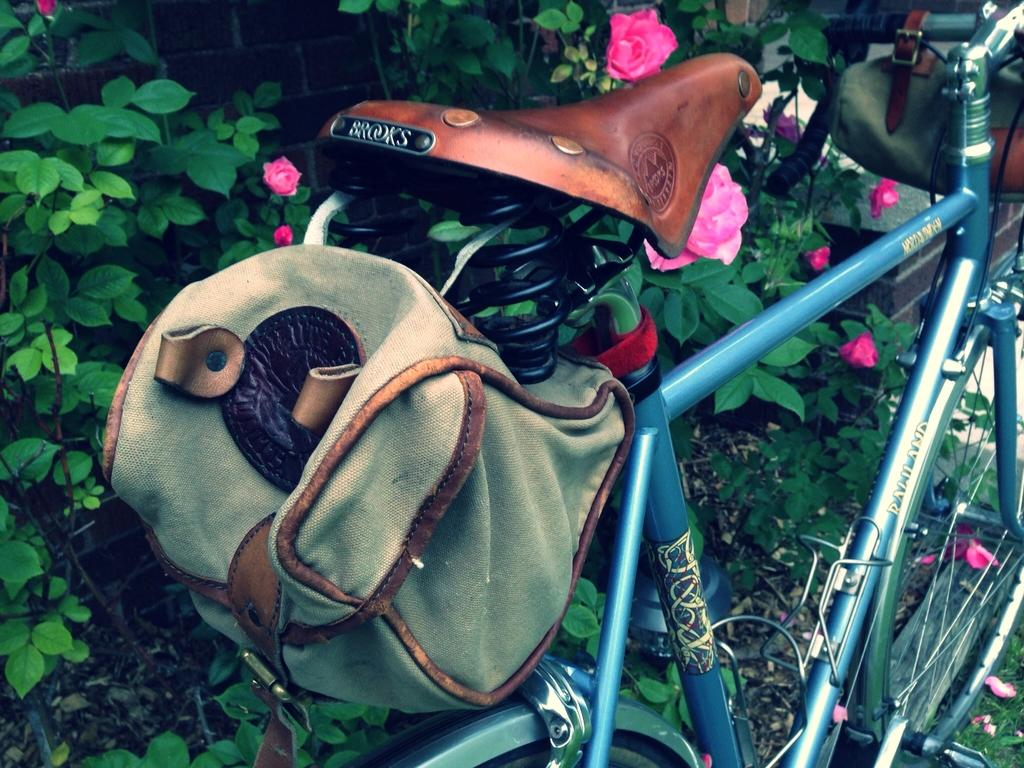What is the main object in the image? There is a bicycle in the image. What is placed on the bicycle? There are bags placed on the bicycle. What can be seen in the background of the image? There are trees in the background of the image. What type of flora is visible in the image? Flowers are visible in the image. What type of cough can be heard in the image? There is no sound or indication of a cough in the image. 